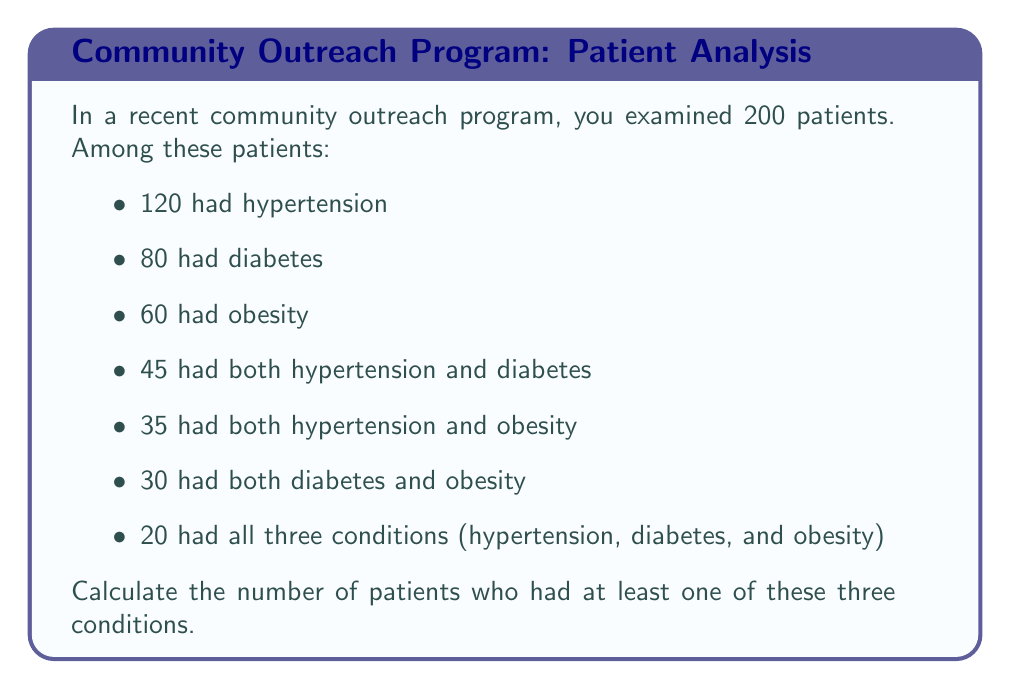Solve this math problem. To solve this problem, we'll use the principle of inclusion-exclusion. Let's define our sets:

$H$ = patients with hypertension
$D$ = patients with diabetes
$O$ = patients with obesity

We want to find $|H \cup D \cup O|$, which is given by the formula:

$$|H \cup D \cup O| = |H| + |D| + |O| - |H \cap D| - |H \cap O| - |D \cap O| + |H \cap D \cap O|$$

We're given:
$|H| = 120$
$|D| = 80$
$|O| = 60$
$|H \cap D| = 45$
$|H \cap O| = 35$
$|D \cap O| = 30$
$|H \cap D \cap O| = 20$

Now, let's substitute these values into our equation:

$$|H \cup D \cup O| = 120 + 80 + 60 - 45 - 35 - 30 + 20$$

$$|H \cup D \cup O| = 260 - 110 + 20$$

$$|H \cup D \cup O| = 170$$

Therefore, 170 patients had at least one of the three conditions.
Answer: 170 patients 